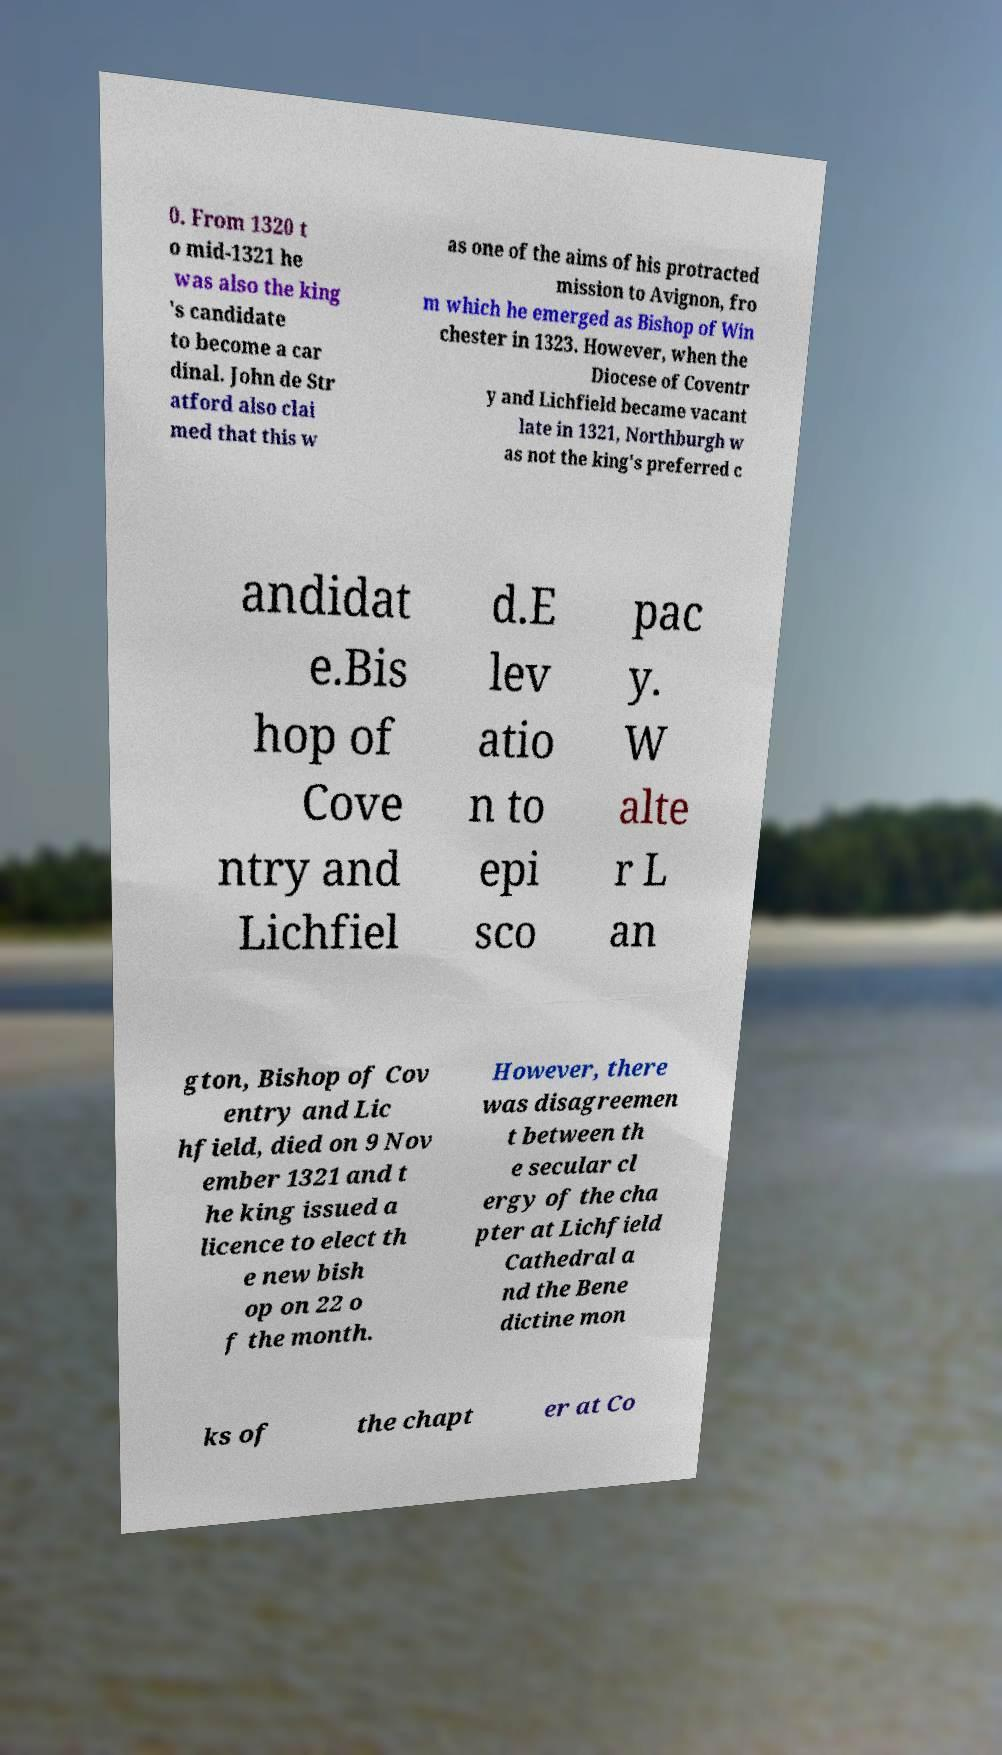Could you assist in decoding the text presented in this image and type it out clearly? 0. From 1320 t o mid-1321 he was also the king 's candidate to become a car dinal. John de Str atford also clai med that this w as one of the aims of his protracted mission to Avignon, fro m which he emerged as Bishop of Win chester in 1323. However, when the Diocese of Coventr y and Lichfield became vacant late in 1321, Northburgh w as not the king's preferred c andidat e.Bis hop of Cove ntry and Lichfiel d.E lev atio n to epi sco pac y. W alte r L an gton, Bishop of Cov entry and Lic hfield, died on 9 Nov ember 1321 and t he king issued a licence to elect th e new bish op on 22 o f the month. However, there was disagreemen t between th e secular cl ergy of the cha pter at Lichfield Cathedral a nd the Bene dictine mon ks of the chapt er at Co 